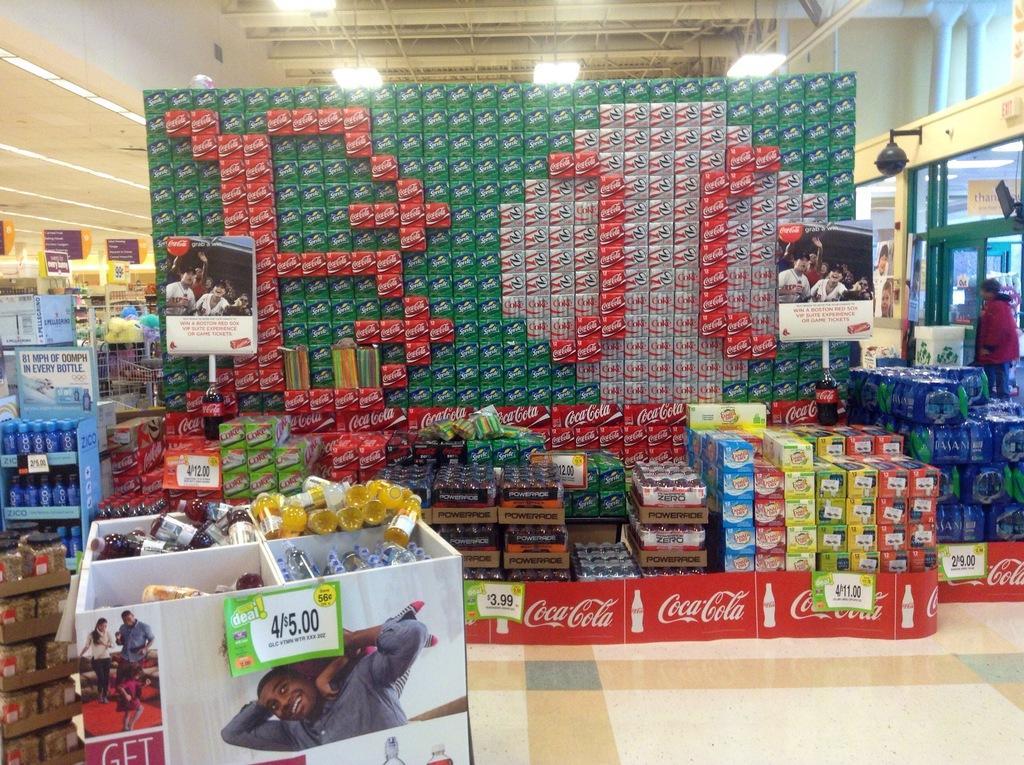Could you give a brief overview of what you see in this image? In this image there is a store, in that store there are stationary items. 